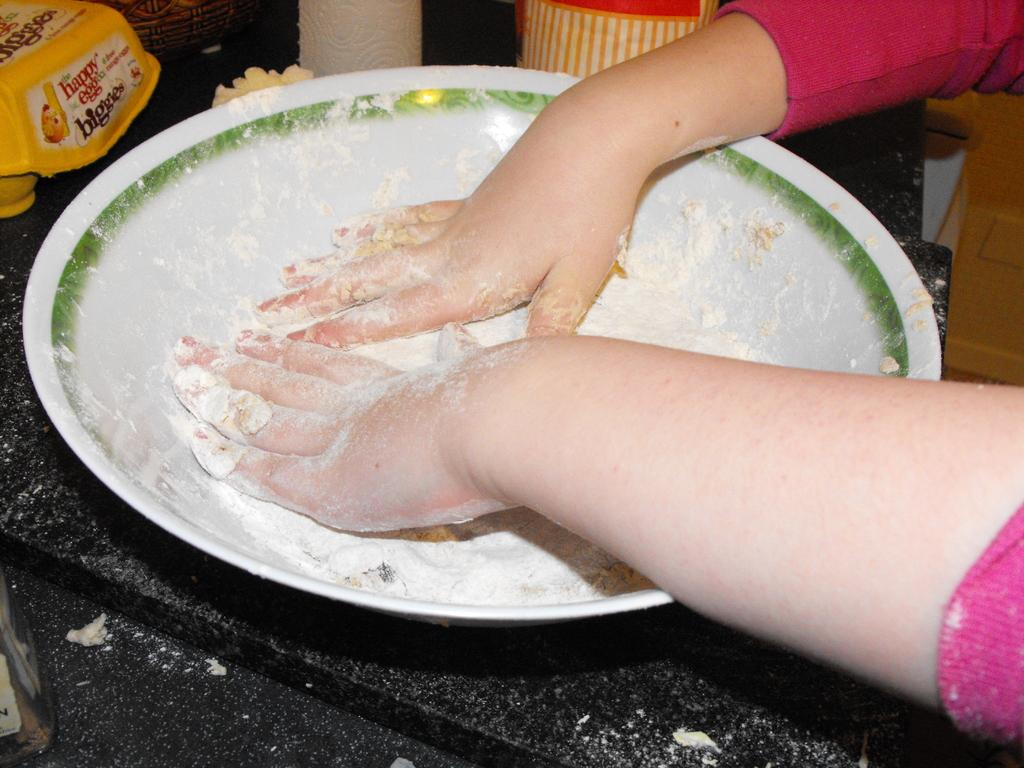Who is present in the image? There is a woman in the image. What is the woman doing with her hands? The woman's hands are in a white bowl. What is the woman mixing in the bowl? The woman is mixing flour in the bowl. Where is the bowl placed? The bowl is placed on a kitchen platform. What can be seen in the background of the image? There is a yellow box and a bread packet in the background. What type of ticket is the woman holding in the image? There is no ticket present in the image; the woman is mixing flour in a bowl. 